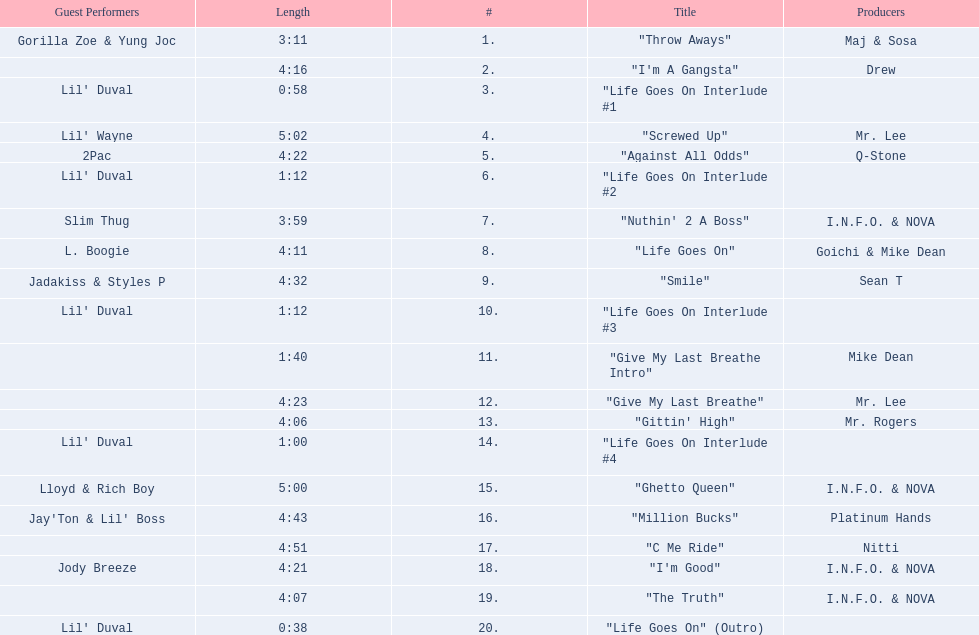What are the song lengths of all the songs on the album? 3:11, 4:16, 0:58, 5:02, 4:22, 1:12, 3:59, 4:11, 4:32, 1:12, 1:40, 4:23, 4:06, 1:00, 5:00, 4:43, 4:51, 4:21, 4:07, 0:38. Which is the longest of these? 5:02. 